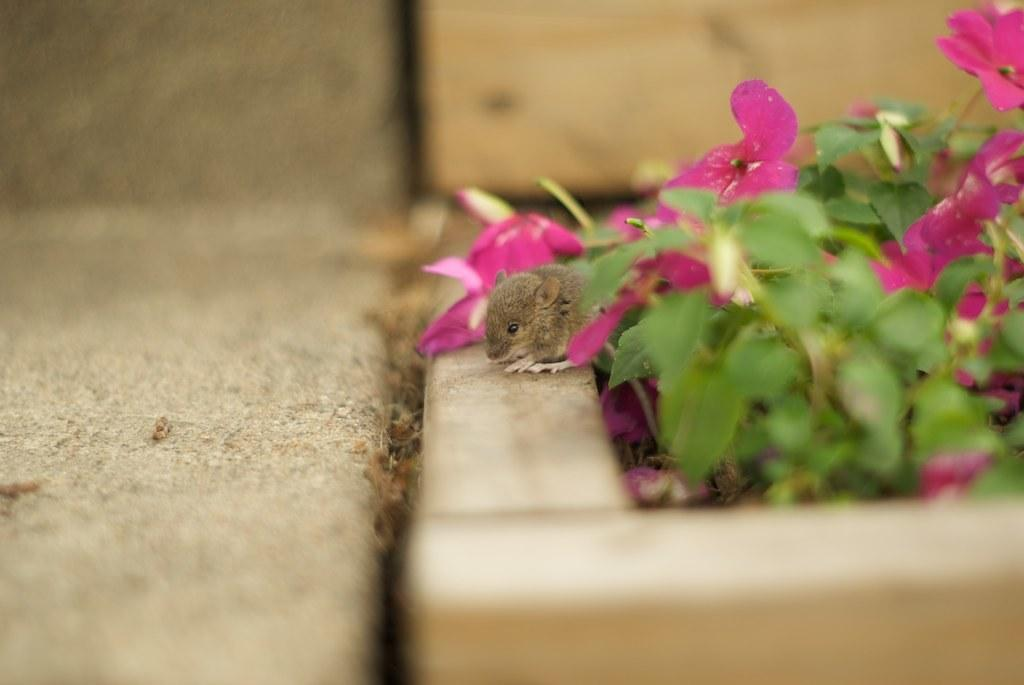What type of animal is present in the image? There is a rat in the image. What other natural elements can be seen in the image? There are flowers and leaves in the image. How would you describe the background of the image? The background of the image is blurred. How many times does the rat taste the flowers in the image? There is no indication in the image that the rat is tasting the flowers, so it cannot be determined from the picture. 